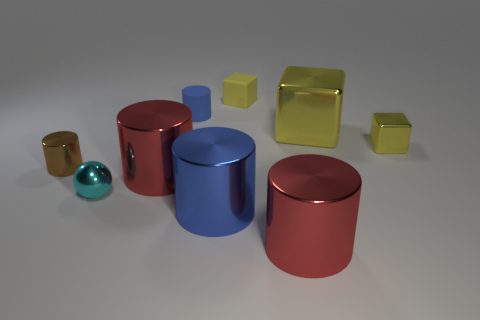Are there more big blue metallic things on the left side of the large blue cylinder than big blue things on the left side of the cyan metallic thing?
Offer a terse response. No. The red cylinder on the right side of the blue cylinder behind the small metallic object that is behind the brown metallic object is made of what material?
Make the answer very short. Metal. There is a big red metal object in front of the blue metal object; does it have the same shape as the small cyan thing in front of the rubber block?
Provide a short and direct response. No. Is there a metal sphere of the same size as the brown cylinder?
Your answer should be very brief. Yes. What number of cyan things are cylinders or tiny blocks?
Your answer should be very brief. 0. How many matte cylinders are the same color as the big metal block?
Your response must be concise. 0. Are there any other things that are the same shape as the big yellow shiny thing?
Provide a succinct answer. Yes. What number of balls are yellow matte things or tiny things?
Your answer should be very brief. 1. What is the color of the thing that is on the left side of the tiny metallic sphere?
Make the answer very short. Brown. The matte thing that is the same size as the rubber block is what shape?
Make the answer very short. Cylinder. 